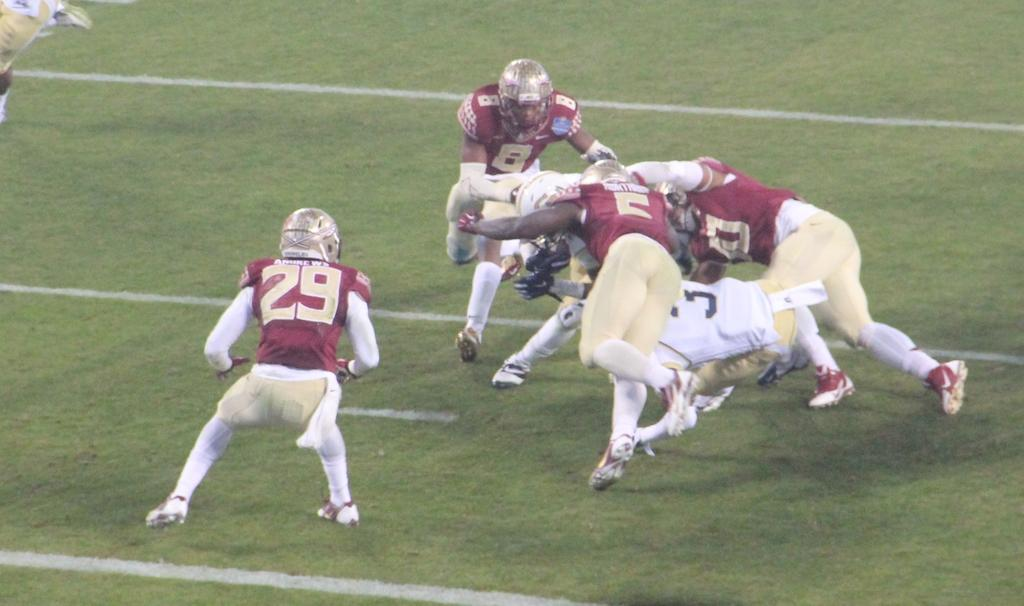What is the main subject of the image? The main subject of the image is a group of people. What are the people wearing in the image? The people are wearing dresses and helmets in the image. Where are the people standing in the image? The people are standing on the ground in the image. What type of humor can be seen in the dresses the people are wearing in the image? There is no humor present in the dresses the people are wearing in the image. Can you describe the box that the people are standing on in the image? There is no box present in the image; the people are standing on the ground. 